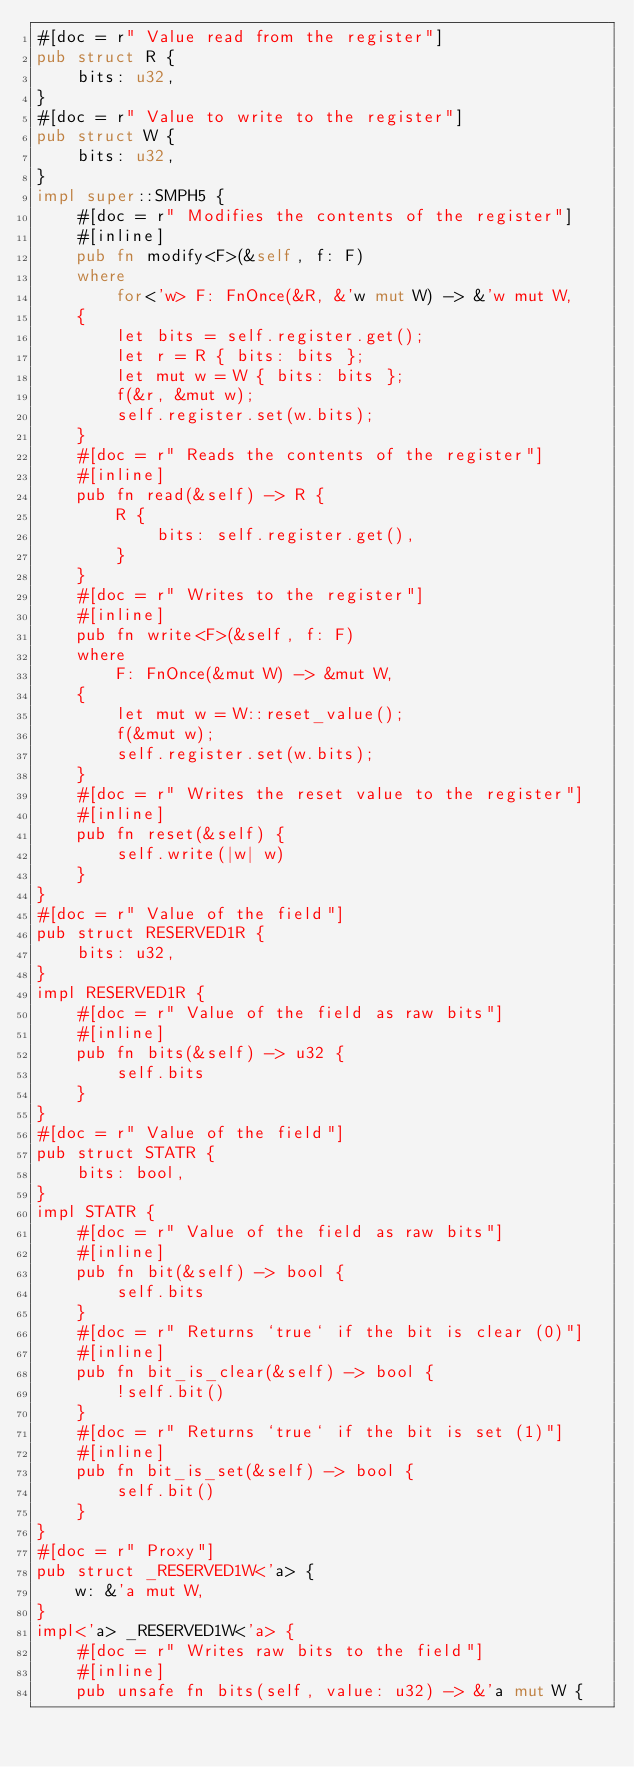<code> <loc_0><loc_0><loc_500><loc_500><_Rust_>#[doc = r" Value read from the register"]
pub struct R {
    bits: u32,
}
#[doc = r" Value to write to the register"]
pub struct W {
    bits: u32,
}
impl super::SMPH5 {
    #[doc = r" Modifies the contents of the register"]
    #[inline]
    pub fn modify<F>(&self, f: F)
    where
        for<'w> F: FnOnce(&R, &'w mut W) -> &'w mut W,
    {
        let bits = self.register.get();
        let r = R { bits: bits };
        let mut w = W { bits: bits };
        f(&r, &mut w);
        self.register.set(w.bits);
    }
    #[doc = r" Reads the contents of the register"]
    #[inline]
    pub fn read(&self) -> R {
        R {
            bits: self.register.get(),
        }
    }
    #[doc = r" Writes to the register"]
    #[inline]
    pub fn write<F>(&self, f: F)
    where
        F: FnOnce(&mut W) -> &mut W,
    {
        let mut w = W::reset_value();
        f(&mut w);
        self.register.set(w.bits);
    }
    #[doc = r" Writes the reset value to the register"]
    #[inline]
    pub fn reset(&self) {
        self.write(|w| w)
    }
}
#[doc = r" Value of the field"]
pub struct RESERVED1R {
    bits: u32,
}
impl RESERVED1R {
    #[doc = r" Value of the field as raw bits"]
    #[inline]
    pub fn bits(&self) -> u32 {
        self.bits
    }
}
#[doc = r" Value of the field"]
pub struct STATR {
    bits: bool,
}
impl STATR {
    #[doc = r" Value of the field as raw bits"]
    #[inline]
    pub fn bit(&self) -> bool {
        self.bits
    }
    #[doc = r" Returns `true` if the bit is clear (0)"]
    #[inline]
    pub fn bit_is_clear(&self) -> bool {
        !self.bit()
    }
    #[doc = r" Returns `true` if the bit is set (1)"]
    #[inline]
    pub fn bit_is_set(&self) -> bool {
        self.bit()
    }
}
#[doc = r" Proxy"]
pub struct _RESERVED1W<'a> {
    w: &'a mut W,
}
impl<'a> _RESERVED1W<'a> {
    #[doc = r" Writes raw bits to the field"]
    #[inline]
    pub unsafe fn bits(self, value: u32) -> &'a mut W {</code> 